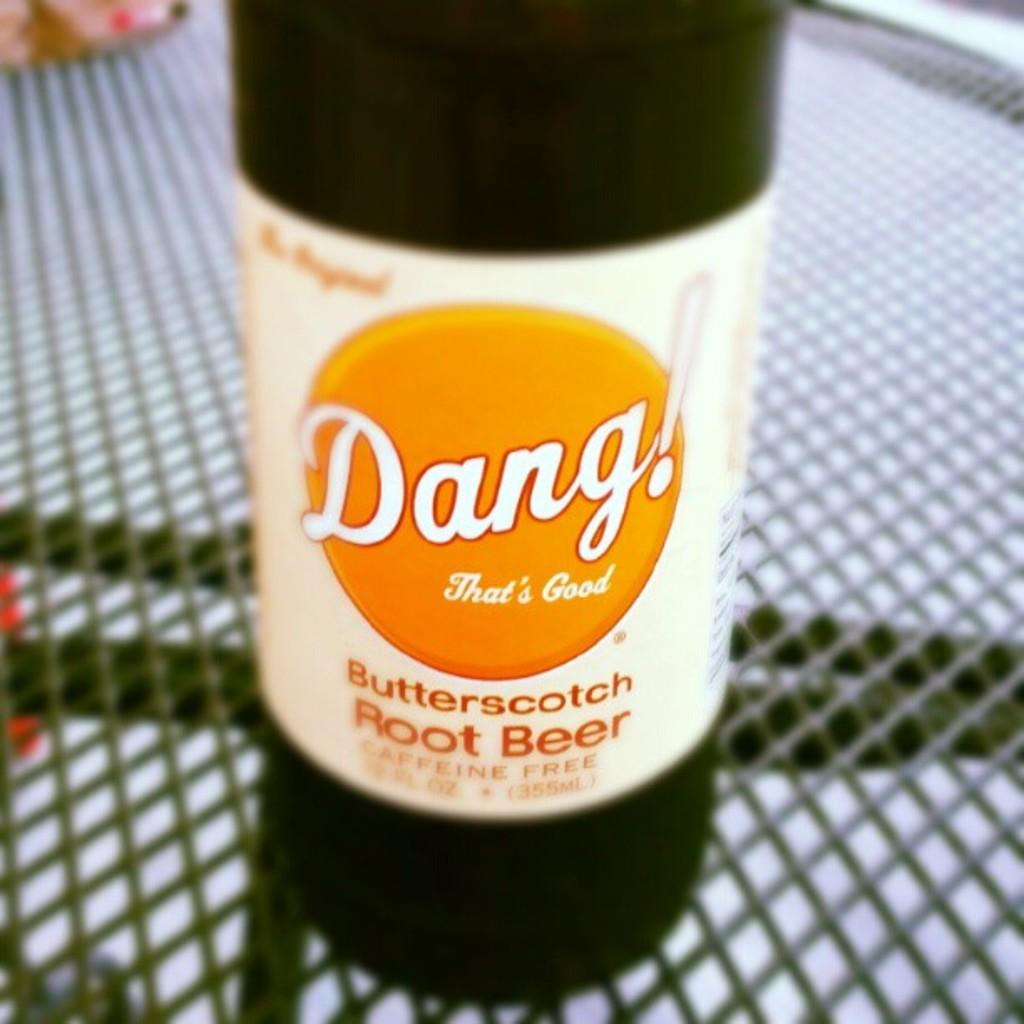<image>
Give a short and clear explanation of the subsequent image. A bottle of butterscotch root beer has a label reading Dang! That's Good. 